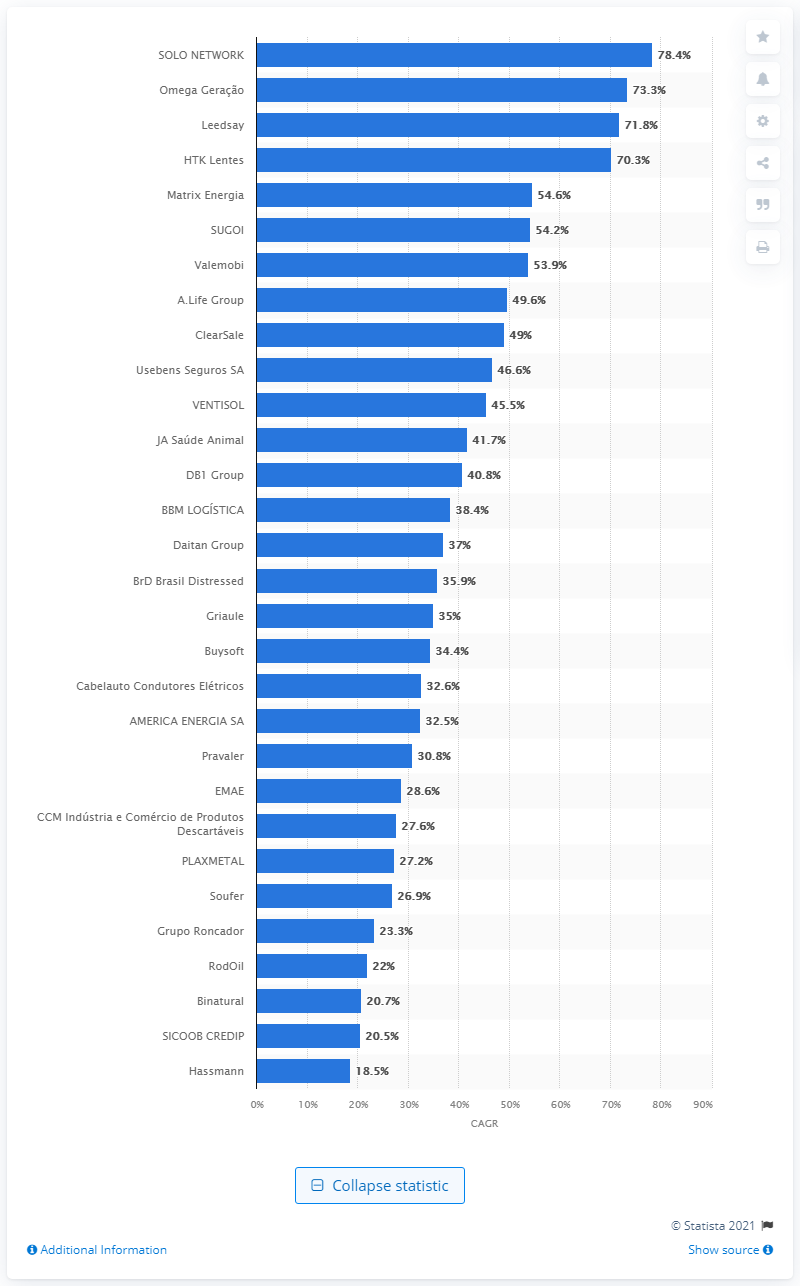Outline some significant characteristics in this image. During the period between 2016 and 2019, the Compound Annual Growth Rate (CAGR) of Solo Network's revenue was 78.4%. The name of the health product manufacturer in Brazil is Leedsay. 